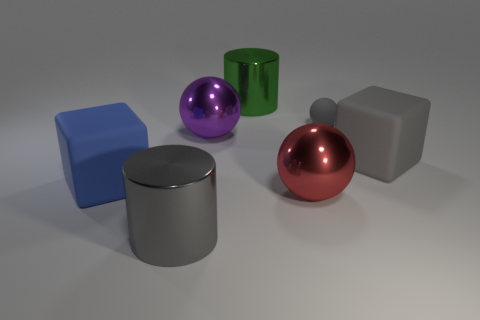What number of other objects are there of the same color as the rubber ball?
Give a very brief answer. 2. Is the big gray metal object the same shape as the big blue rubber thing?
Provide a short and direct response. No. Does the gray object on the left side of the green cylinder have the same size as the tiny gray matte thing?
Provide a short and direct response. No. The other object that is the same shape as the blue object is what color?
Offer a terse response. Gray. There is a gray matte thing in front of the small gray sphere; what shape is it?
Your answer should be compact. Cube. How many other big rubber objects have the same shape as the blue object?
Keep it short and to the point. 1. Is the color of the large matte object that is to the right of the gray shiny cylinder the same as the large cylinder that is in front of the big gray block?
Give a very brief answer. Yes. How many objects are large red metal cylinders or green cylinders?
Keep it short and to the point. 1. What number of big blue cubes have the same material as the purple sphere?
Your answer should be very brief. 0. Is the number of small gray matte spheres less than the number of tiny metallic balls?
Provide a short and direct response. No. 